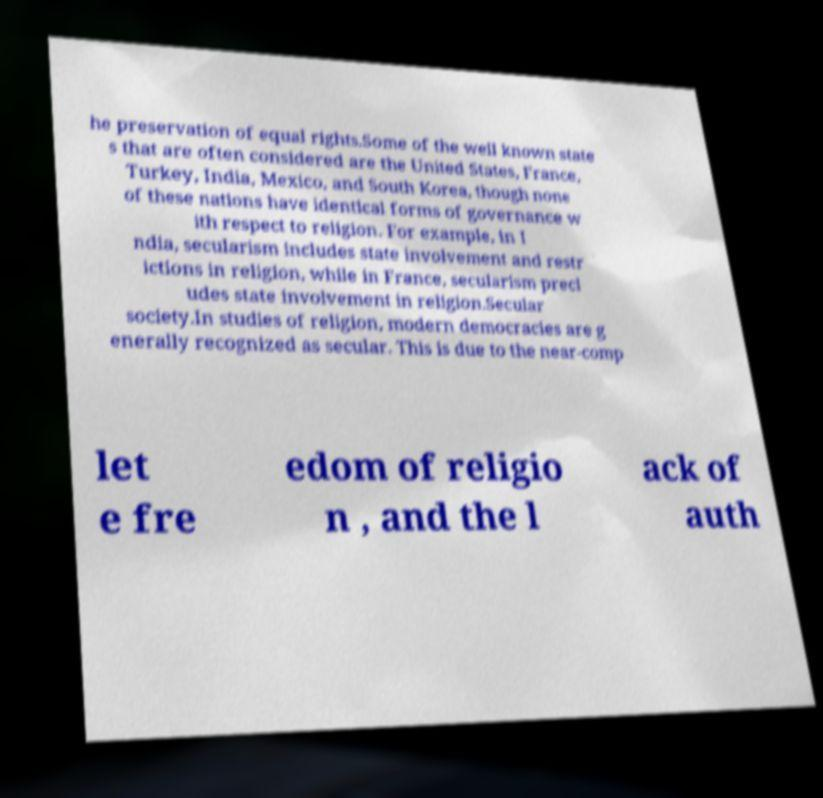Could you extract and type out the text from this image? he preservation of equal rights.Some of the well known state s that are often considered are the United States, France, Turkey, India, Mexico, and South Korea, though none of these nations have identical forms of governance w ith respect to religion. For example, in I ndia, secularism includes state involvement and restr ictions in religion, while in France, secularism precl udes state involvement in religion.Secular society.In studies of religion, modern democracies are g enerally recognized as secular. This is due to the near-comp let e fre edom of religio n , and the l ack of auth 